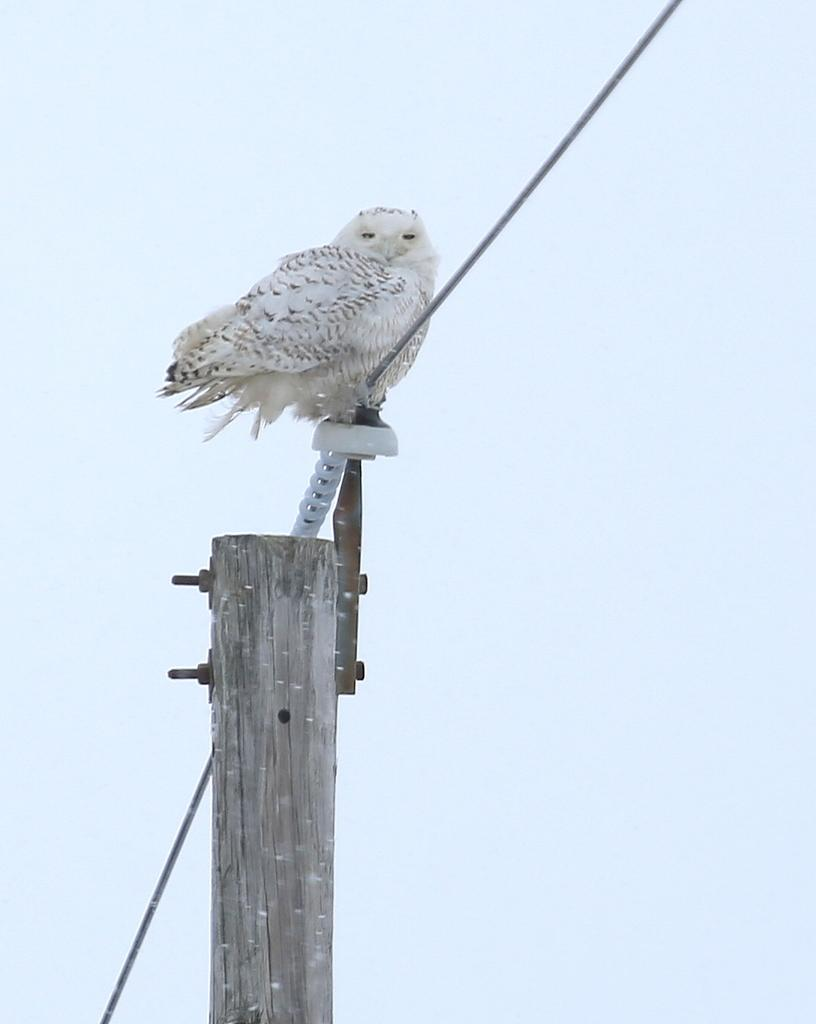What is the main object in the image? There is a pole in the image. What animal can be seen in the image? There is a white color owl in the image. Where is the owl located in the image? The owl is sitting on the top of an electric cable wire. What type of coat is the chicken wearing in the image? There is no chicken present in the image, and therefore no coat can be observed. 